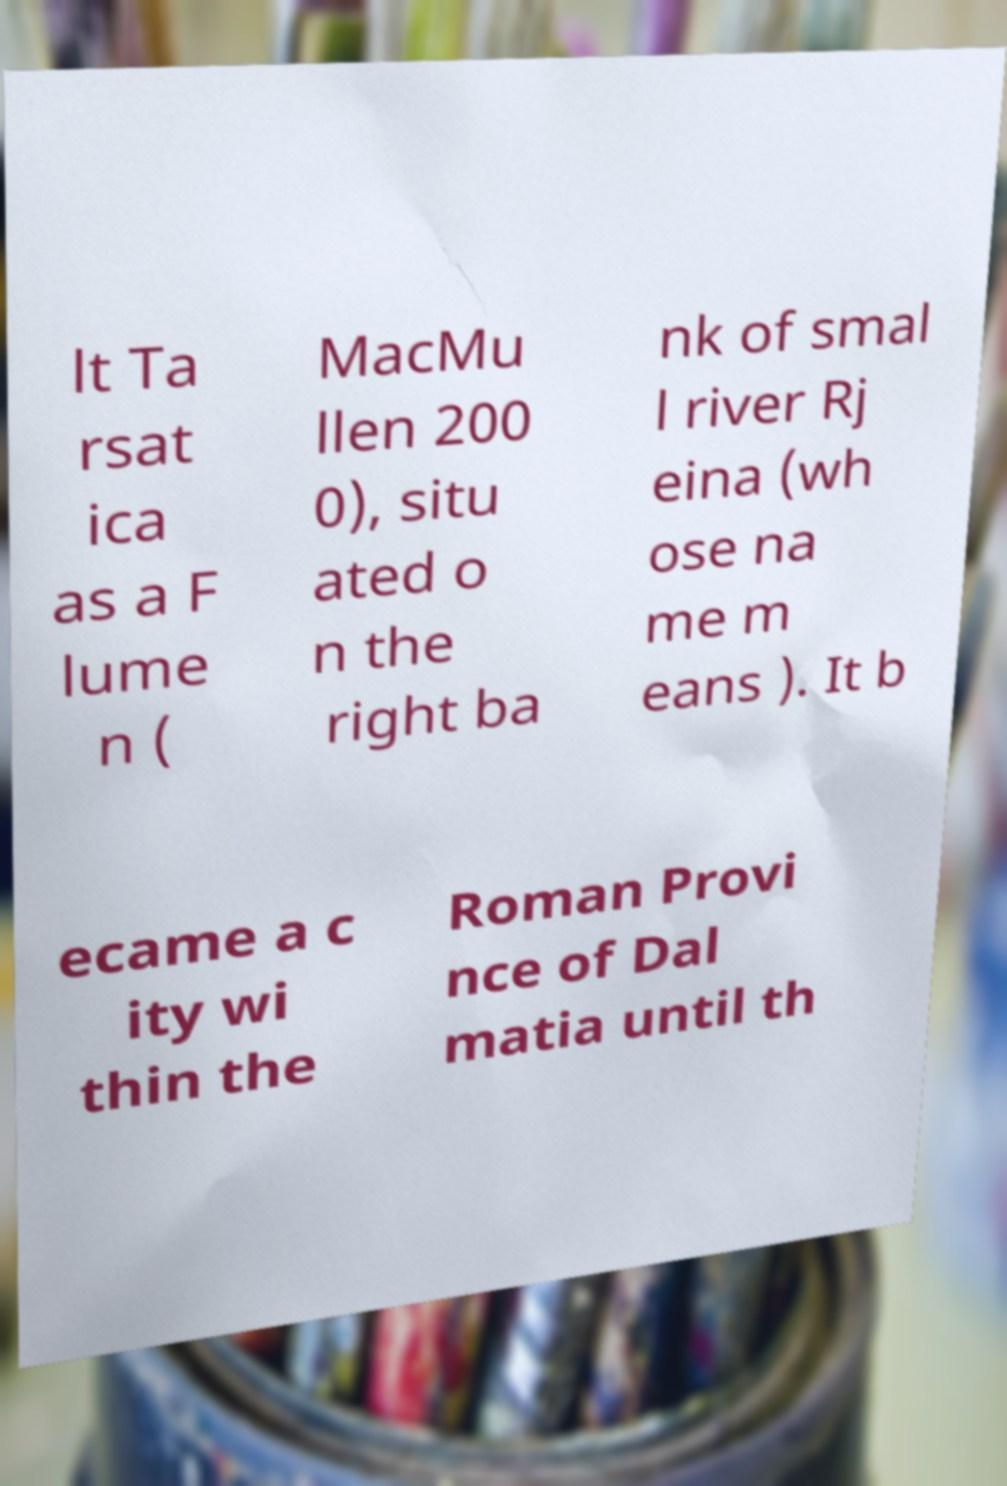Can you read and provide the text displayed in the image?This photo seems to have some interesting text. Can you extract and type it out for me? lt Ta rsat ica as a F lume n ( MacMu llen 200 0), situ ated o n the right ba nk of smal l river Rj eina (wh ose na me m eans ). It b ecame a c ity wi thin the Roman Provi nce of Dal matia until th 